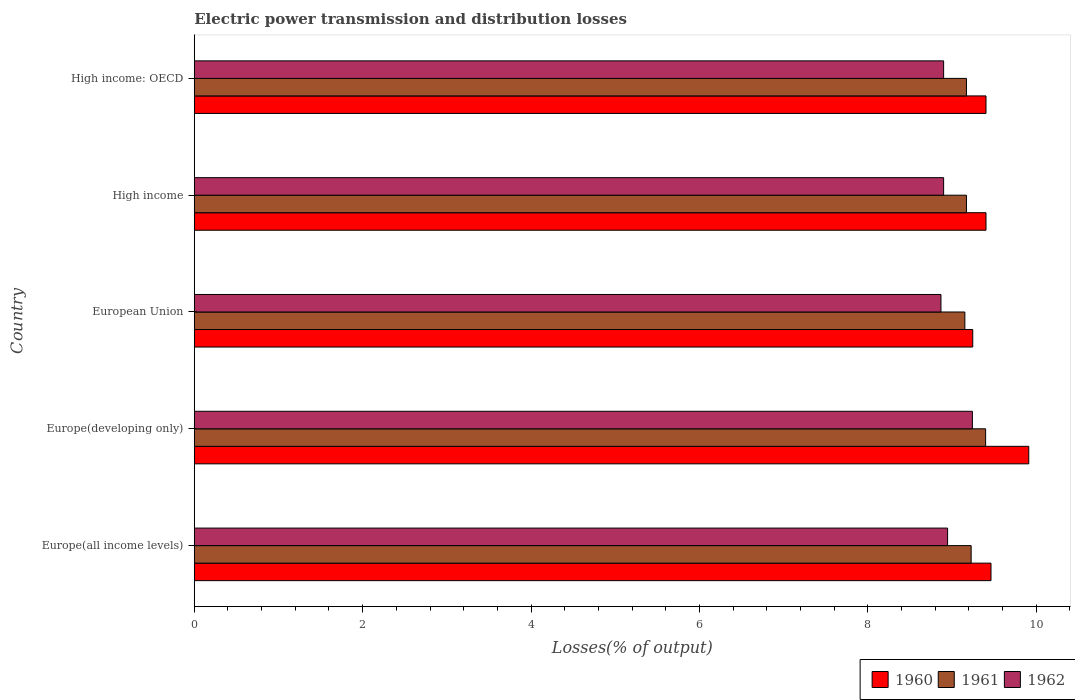How many different coloured bars are there?
Make the answer very short. 3. Are the number of bars per tick equal to the number of legend labels?
Keep it short and to the point. Yes. Are the number of bars on each tick of the Y-axis equal?
Give a very brief answer. Yes. What is the label of the 5th group of bars from the top?
Your response must be concise. Europe(all income levels). What is the electric power transmission and distribution losses in 1962 in High income?
Provide a short and direct response. 8.9. Across all countries, what is the maximum electric power transmission and distribution losses in 1962?
Your answer should be very brief. 9.24. Across all countries, what is the minimum electric power transmission and distribution losses in 1962?
Your answer should be very brief. 8.87. In which country was the electric power transmission and distribution losses in 1961 maximum?
Your answer should be very brief. Europe(developing only). In which country was the electric power transmission and distribution losses in 1960 minimum?
Make the answer very short. European Union. What is the total electric power transmission and distribution losses in 1960 in the graph?
Make the answer very short. 47.43. What is the difference between the electric power transmission and distribution losses in 1960 in High income and that in High income: OECD?
Ensure brevity in your answer.  0. What is the difference between the electric power transmission and distribution losses in 1960 in Europe(all income levels) and the electric power transmission and distribution losses in 1962 in Europe(developing only)?
Offer a terse response. 0.22. What is the average electric power transmission and distribution losses in 1960 per country?
Give a very brief answer. 9.49. What is the difference between the electric power transmission and distribution losses in 1961 and electric power transmission and distribution losses in 1960 in Europe(all income levels)?
Your response must be concise. -0.24. In how many countries, is the electric power transmission and distribution losses in 1962 greater than 8.4 %?
Keep it short and to the point. 5. What is the ratio of the electric power transmission and distribution losses in 1962 in Europe(developing only) to that in High income: OECD?
Your answer should be very brief. 1.04. Is the electric power transmission and distribution losses in 1962 in High income less than that in High income: OECD?
Give a very brief answer. No. What is the difference between the highest and the second highest electric power transmission and distribution losses in 1962?
Your answer should be very brief. 0.29. What is the difference between the highest and the lowest electric power transmission and distribution losses in 1960?
Provide a short and direct response. 0.67. In how many countries, is the electric power transmission and distribution losses in 1962 greater than the average electric power transmission and distribution losses in 1962 taken over all countries?
Provide a short and direct response. 1. Is the sum of the electric power transmission and distribution losses in 1961 in European Union and High income: OECD greater than the maximum electric power transmission and distribution losses in 1962 across all countries?
Keep it short and to the point. Yes. What does the 1st bar from the bottom in Europe(all income levels) represents?
Offer a terse response. 1960. How many bars are there?
Offer a very short reply. 15. How many countries are there in the graph?
Offer a terse response. 5. What is the difference between two consecutive major ticks on the X-axis?
Ensure brevity in your answer.  2. Are the values on the major ticks of X-axis written in scientific E-notation?
Provide a short and direct response. No. Does the graph contain any zero values?
Offer a terse response. No. Does the graph contain grids?
Make the answer very short. No. How many legend labels are there?
Give a very brief answer. 3. How are the legend labels stacked?
Keep it short and to the point. Horizontal. What is the title of the graph?
Your response must be concise. Electric power transmission and distribution losses. Does "1986" appear as one of the legend labels in the graph?
Ensure brevity in your answer.  No. What is the label or title of the X-axis?
Ensure brevity in your answer.  Losses(% of output). What is the label or title of the Y-axis?
Give a very brief answer. Country. What is the Losses(% of output) in 1960 in Europe(all income levels)?
Make the answer very short. 9.46. What is the Losses(% of output) in 1961 in Europe(all income levels)?
Your answer should be very brief. 9.23. What is the Losses(% of output) of 1962 in Europe(all income levels)?
Offer a terse response. 8.95. What is the Losses(% of output) in 1960 in Europe(developing only)?
Your answer should be very brief. 9.91. What is the Losses(% of output) in 1961 in Europe(developing only)?
Your response must be concise. 9.4. What is the Losses(% of output) in 1962 in Europe(developing only)?
Provide a succinct answer. 9.24. What is the Losses(% of output) of 1960 in European Union?
Your response must be concise. 9.25. What is the Losses(% of output) in 1961 in European Union?
Give a very brief answer. 9.15. What is the Losses(% of output) of 1962 in European Union?
Offer a terse response. 8.87. What is the Losses(% of output) in 1960 in High income?
Give a very brief answer. 9.4. What is the Losses(% of output) of 1961 in High income?
Offer a terse response. 9.17. What is the Losses(% of output) of 1962 in High income?
Your answer should be very brief. 8.9. What is the Losses(% of output) of 1960 in High income: OECD?
Provide a short and direct response. 9.4. What is the Losses(% of output) of 1961 in High income: OECD?
Your answer should be very brief. 9.17. What is the Losses(% of output) in 1962 in High income: OECD?
Provide a short and direct response. 8.9. Across all countries, what is the maximum Losses(% of output) of 1960?
Keep it short and to the point. 9.91. Across all countries, what is the maximum Losses(% of output) in 1961?
Your answer should be compact. 9.4. Across all countries, what is the maximum Losses(% of output) in 1962?
Provide a short and direct response. 9.24. Across all countries, what is the minimum Losses(% of output) of 1960?
Ensure brevity in your answer.  9.25. Across all countries, what is the minimum Losses(% of output) in 1961?
Your answer should be very brief. 9.15. Across all countries, what is the minimum Losses(% of output) of 1962?
Provide a short and direct response. 8.87. What is the total Losses(% of output) in 1960 in the graph?
Your response must be concise. 47.43. What is the total Losses(% of output) in 1961 in the graph?
Offer a terse response. 46.12. What is the total Losses(% of output) of 1962 in the graph?
Offer a very short reply. 44.86. What is the difference between the Losses(% of output) in 1960 in Europe(all income levels) and that in Europe(developing only)?
Your response must be concise. -0.45. What is the difference between the Losses(% of output) of 1961 in Europe(all income levels) and that in Europe(developing only)?
Your answer should be compact. -0.17. What is the difference between the Losses(% of output) of 1962 in Europe(all income levels) and that in Europe(developing only)?
Ensure brevity in your answer.  -0.29. What is the difference between the Losses(% of output) of 1960 in Europe(all income levels) and that in European Union?
Make the answer very short. 0.22. What is the difference between the Losses(% of output) of 1961 in Europe(all income levels) and that in European Union?
Your answer should be compact. 0.07. What is the difference between the Losses(% of output) of 1962 in Europe(all income levels) and that in European Union?
Keep it short and to the point. 0.08. What is the difference between the Losses(% of output) of 1960 in Europe(all income levels) and that in High income?
Make the answer very short. 0.06. What is the difference between the Losses(% of output) in 1961 in Europe(all income levels) and that in High income?
Provide a short and direct response. 0.06. What is the difference between the Losses(% of output) in 1962 in Europe(all income levels) and that in High income?
Your answer should be compact. 0.05. What is the difference between the Losses(% of output) of 1960 in Europe(all income levels) and that in High income: OECD?
Your response must be concise. 0.06. What is the difference between the Losses(% of output) in 1961 in Europe(all income levels) and that in High income: OECD?
Give a very brief answer. 0.06. What is the difference between the Losses(% of output) in 1962 in Europe(all income levels) and that in High income: OECD?
Keep it short and to the point. 0.05. What is the difference between the Losses(% of output) of 1960 in Europe(developing only) and that in European Union?
Offer a terse response. 0.67. What is the difference between the Losses(% of output) of 1961 in Europe(developing only) and that in European Union?
Keep it short and to the point. 0.25. What is the difference between the Losses(% of output) of 1962 in Europe(developing only) and that in European Union?
Offer a terse response. 0.37. What is the difference between the Losses(% of output) in 1960 in Europe(developing only) and that in High income?
Offer a terse response. 0.51. What is the difference between the Losses(% of output) of 1961 in Europe(developing only) and that in High income?
Offer a terse response. 0.23. What is the difference between the Losses(% of output) in 1962 in Europe(developing only) and that in High income?
Make the answer very short. 0.34. What is the difference between the Losses(% of output) of 1960 in Europe(developing only) and that in High income: OECD?
Your answer should be very brief. 0.51. What is the difference between the Losses(% of output) in 1961 in Europe(developing only) and that in High income: OECD?
Keep it short and to the point. 0.23. What is the difference between the Losses(% of output) in 1962 in Europe(developing only) and that in High income: OECD?
Ensure brevity in your answer.  0.34. What is the difference between the Losses(% of output) of 1960 in European Union and that in High income?
Your answer should be compact. -0.16. What is the difference between the Losses(% of output) of 1961 in European Union and that in High income?
Provide a succinct answer. -0.02. What is the difference between the Losses(% of output) in 1962 in European Union and that in High income?
Make the answer very short. -0.03. What is the difference between the Losses(% of output) in 1960 in European Union and that in High income: OECD?
Your answer should be compact. -0.16. What is the difference between the Losses(% of output) in 1961 in European Union and that in High income: OECD?
Offer a very short reply. -0.02. What is the difference between the Losses(% of output) in 1962 in European Union and that in High income: OECD?
Offer a terse response. -0.03. What is the difference between the Losses(% of output) in 1961 in High income and that in High income: OECD?
Your response must be concise. 0. What is the difference between the Losses(% of output) of 1962 in High income and that in High income: OECD?
Offer a terse response. 0. What is the difference between the Losses(% of output) in 1960 in Europe(all income levels) and the Losses(% of output) in 1961 in Europe(developing only)?
Ensure brevity in your answer.  0.06. What is the difference between the Losses(% of output) in 1960 in Europe(all income levels) and the Losses(% of output) in 1962 in Europe(developing only)?
Keep it short and to the point. 0.22. What is the difference between the Losses(% of output) of 1961 in Europe(all income levels) and the Losses(% of output) of 1962 in Europe(developing only)?
Offer a very short reply. -0.01. What is the difference between the Losses(% of output) of 1960 in Europe(all income levels) and the Losses(% of output) of 1961 in European Union?
Provide a short and direct response. 0.31. What is the difference between the Losses(% of output) of 1960 in Europe(all income levels) and the Losses(% of output) of 1962 in European Union?
Your answer should be very brief. 0.59. What is the difference between the Losses(% of output) of 1961 in Europe(all income levels) and the Losses(% of output) of 1962 in European Union?
Offer a terse response. 0.36. What is the difference between the Losses(% of output) of 1960 in Europe(all income levels) and the Losses(% of output) of 1961 in High income?
Your answer should be very brief. 0.29. What is the difference between the Losses(% of output) of 1960 in Europe(all income levels) and the Losses(% of output) of 1962 in High income?
Provide a short and direct response. 0.56. What is the difference between the Losses(% of output) in 1961 in Europe(all income levels) and the Losses(% of output) in 1962 in High income?
Your response must be concise. 0.33. What is the difference between the Losses(% of output) of 1960 in Europe(all income levels) and the Losses(% of output) of 1961 in High income: OECD?
Make the answer very short. 0.29. What is the difference between the Losses(% of output) in 1960 in Europe(all income levels) and the Losses(% of output) in 1962 in High income: OECD?
Offer a terse response. 0.56. What is the difference between the Losses(% of output) of 1961 in Europe(all income levels) and the Losses(% of output) of 1962 in High income: OECD?
Your answer should be very brief. 0.33. What is the difference between the Losses(% of output) in 1960 in Europe(developing only) and the Losses(% of output) in 1961 in European Union?
Your answer should be very brief. 0.76. What is the difference between the Losses(% of output) of 1960 in Europe(developing only) and the Losses(% of output) of 1962 in European Union?
Offer a very short reply. 1.04. What is the difference between the Losses(% of output) of 1961 in Europe(developing only) and the Losses(% of output) of 1962 in European Union?
Provide a succinct answer. 0.53. What is the difference between the Losses(% of output) of 1960 in Europe(developing only) and the Losses(% of output) of 1961 in High income?
Offer a terse response. 0.74. What is the difference between the Losses(% of output) of 1960 in Europe(developing only) and the Losses(% of output) of 1962 in High income?
Make the answer very short. 1.01. What is the difference between the Losses(% of output) of 1961 in Europe(developing only) and the Losses(% of output) of 1962 in High income?
Your response must be concise. 0.5. What is the difference between the Losses(% of output) of 1960 in Europe(developing only) and the Losses(% of output) of 1961 in High income: OECD?
Provide a succinct answer. 0.74. What is the difference between the Losses(% of output) in 1960 in Europe(developing only) and the Losses(% of output) in 1962 in High income: OECD?
Your answer should be compact. 1.01. What is the difference between the Losses(% of output) of 1961 in Europe(developing only) and the Losses(% of output) of 1962 in High income: OECD?
Your response must be concise. 0.5. What is the difference between the Losses(% of output) in 1960 in European Union and the Losses(% of output) in 1961 in High income?
Offer a very short reply. 0.07. What is the difference between the Losses(% of output) of 1960 in European Union and the Losses(% of output) of 1962 in High income?
Your response must be concise. 0.35. What is the difference between the Losses(% of output) in 1961 in European Union and the Losses(% of output) in 1962 in High income?
Give a very brief answer. 0.25. What is the difference between the Losses(% of output) in 1960 in European Union and the Losses(% of output) in 1961 in High income: OECD?
Offer a terse response. 0.07. What is the difference between the Losses(% of output) of 1960 in European Union and the Losses(% of output) of 1962 in High income: OECD?
Keep it short and to the point. 0.35. What is the difference between the Losses(% of output) in 1961 in European Union and the Losses(% of output) in 1962 in High income: OECD?
Keep it short and to the point. 0.25. What is the difference between the Losses(% of output) of 1960 in High income and the Losses(% of output) of 1961 in High income: OECD?
Your answer should be compact. 0.23. What is the difference between the Losses(% of output) of 1960 in High income and the Losses(% of output) of 1962 in High income: OECD?
Your answer should be compact. 0.5. What is the difference between the Losses(% of output) in 1961 in High income and the Losses(% of output) in 1962 in High income: OECD?
Your answer should be compact. 0.27. What is the average Losses(% of output) of 1960 per country?
Your answer should be very brief. 9.49. What is the average Losses(% of output) in 1961 per country?
Give a very brief answer. 9.22. What is the average Losses(% of output) of 1962 per country?
Provide a succinct answer. 8.97. What is the difference between the Losses(% of output) of 1960 and Losses(% of output) of 1961 in Europe(all income levels)?
Your response must be concise. 0.24. What is the difference between the Losses(% of output) in 1960 and Losses(% of output) in 1962 in Europe(all income levels)?
Your answer should be very brief. 0.52. What is the difference between the Losses(% of output) in 1961 and Losses(% of output) in 1962 in Europe(all income levels)?
Keep it short and to the point. 0.28. What is the difference between the Losses(% of output) of 1960 and Losses(% of output) of 1961 in Europe(developing only)?
Keep it short and to the point. 0.51. What is the difference between the Losses(% of output) in 1960 and Losses(% of output) in 1962 in Europe(developing only)?
Ensure brevity in your answer.  0.67. What is the difference between the Losses(% of output) in 1961 and Losses(% of output) in 1962 in Europe(developing only)?
Keep it short and to the point. 0.16. What is the difference between the Losses(% of output) of 1960 and Losses(% of output) of 1961 in European Union?
Provide a succinct answer. 0.09. What is the difference between the Losses(% of output) in 1960 and Losses(% of output) in 1962 in European Union?
Make the answer very short. 0.38. What is the difference between the Losses(% of output) of 1961 and Losses(% of output) of 1962 in European Union?
Make the answer very short. 0.28. What is the difference between the Losses(% of output) of 1960 and Losses(% of output) of 1961 in High income?
Provide a short and direct response. 0.23. What is the difference between the Losses(% of output) in 1960 and Losses(% of output) in 1962 in High income?
Offer a terse response. 0.5. What is the difference between the Losses(% of output) of 1961 and Losses(% of output) of 1962 in High income?
Keep it short and to the point. 0.27. What is the difference between the Losses(% of output) in 1960 and Losses(% of output) in 1961 in High income: OECD?
Your answer should be compact. 0.23. What is the difference between the Losses(% of output) in 1960 and Losses(% of output) in 1962 in High income: OECD?
Ensure brevity in your answer.  0.5. What is the difference between the Losses(% of output) of 1961 and Losses(% of output) of 1962 in High income: OECD?
Your answer should be very brief. 0.27. What is the ratio of the Losses(% of output) in 1960 in Europe(all income levels) to that in Europe(developing only)?
Keep it short and to the point. 0.95. What is the ratio of the Losses(% of output) in 1961 in Europe(all income levels) to that in Europe(developing only)?
Your answer should be compact. 0.98. What is the ratio of the Losses(% of output) of 1962 in Europe(all income levels) to that in Europe(developing only)?
Make the answer very short. 0.97. What is the ratio of the Losses(% of output) in 1960 in Europe(all income levels) to that in European Union?
Provide a succinct answer. 1.02. What is the ratio of the Losses(% of output) in 1961 in Europe(all income levels) to that in European Union?
Keep it short and to the point. 1.01. What is the ratio of the Losses(% of output) in 1962 in Europe(all income levels) to that in European Union?
Ensure brevity in your answer.  1.01. What is the ratio of the Losses(% of output) of 1962 in Europe(all income levels) to that in High income?
Your answer should be compact. 1.01. What is the ratio of the Losses(% of output) of 1960 in Europe(developing only) to that in European Union?
Provide a succinct answer. 1.07. What is the ratio of the Losses(% of output) of 1961 in Europe(developing only) to that in European Union?
Provide a short and direct response. 1.03. What is the ratio of the Losses(% of output) in 1962 in Europe(developing only) to that in European Union?
Give a very brief answer. 1.04. What is the ratio of the Losses(% of output) in 1960 in Europe(developing only) to that in High income?
Offer a terse response. 1.05. What is the ratio of the Losses(% of output) of 1961 in Europe(developing only) to that in High income?
Provide a succinct answer. 1.02. What is the ratio of the Losses(% of output) in 1962 in Europe(developing only) to that in High income?
Offer a terse response. 1.04. What is the ratio of the Losses(% of output) in 1960 in Europe(developing only) to that in High income: OECD?
Your response must be concise. 1.05. What is the ratio of the Losses(% of output) of 1961 in Europe(developing only) to that in High income: OECD?
Offer a terse response. 1.02. What is the ratio of the Losses(% of output) of 1962 in Europe(developing only) to that in High income: OECD?
Make the answer very short. 1.04. What is the ratio of the Losses(% of output) of 1960 in European Union to that in High income?
Offer a very short reply. 0.98. What is the ratio of the Losses(% of output) of 1961 in European Union to that in High income?
Provide a succinct answer. 1. What is the ratio of the Losses(% of output) of 1962 in European Union to that in High income?
Your answer should be very brief. 1. What is the ratio of the Losses(% of output) in 1960 in European Union to that in High income: OECD?
Ensure brevity in your answer.  0.98. What is the ratio of the Losses(% of output) of 1960 in High income to that in High income: OECD?
Offer a terse response. 1. What is the ratio of the Losses(% of output) in 1961 in High income to that in High income: OECD?
Ensure brevity in your answer.  1. What is the ratio of the Losses(% of output) in 1962 in High income to that in High income: OECD?
Provide a succinct answer. 1. What is the difference between the highest and the second highest Losses(% of output) in 1960?
Your response must be concise. 0.45. What is the difference between the highest and the second highest Losses(% of output) of 1961?
Make the answer very short. 0.17. What is the difference between the highest and the second highest Losses(% of output) in 1962?
Your answer should be compact. 0.29. What is the difference between the highest and the lowest Losses(% of output) of 1960?
Your answer should be very brief. 0.67. What is the difference between the highest and the lowest Losses(% of output) in 1961?
Your response must be concise. 0.25. What is the difference between the highest and the lowest Losses(% of output) of 1962?
Provide a short and direct response. 0.37. 